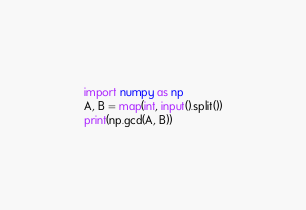<code> <loc_0><loc_0><loc_500><loc_500><_Python_>import numpy as np
A, B = map(int, input().split())
print(np.gcd(A, B))</code> 